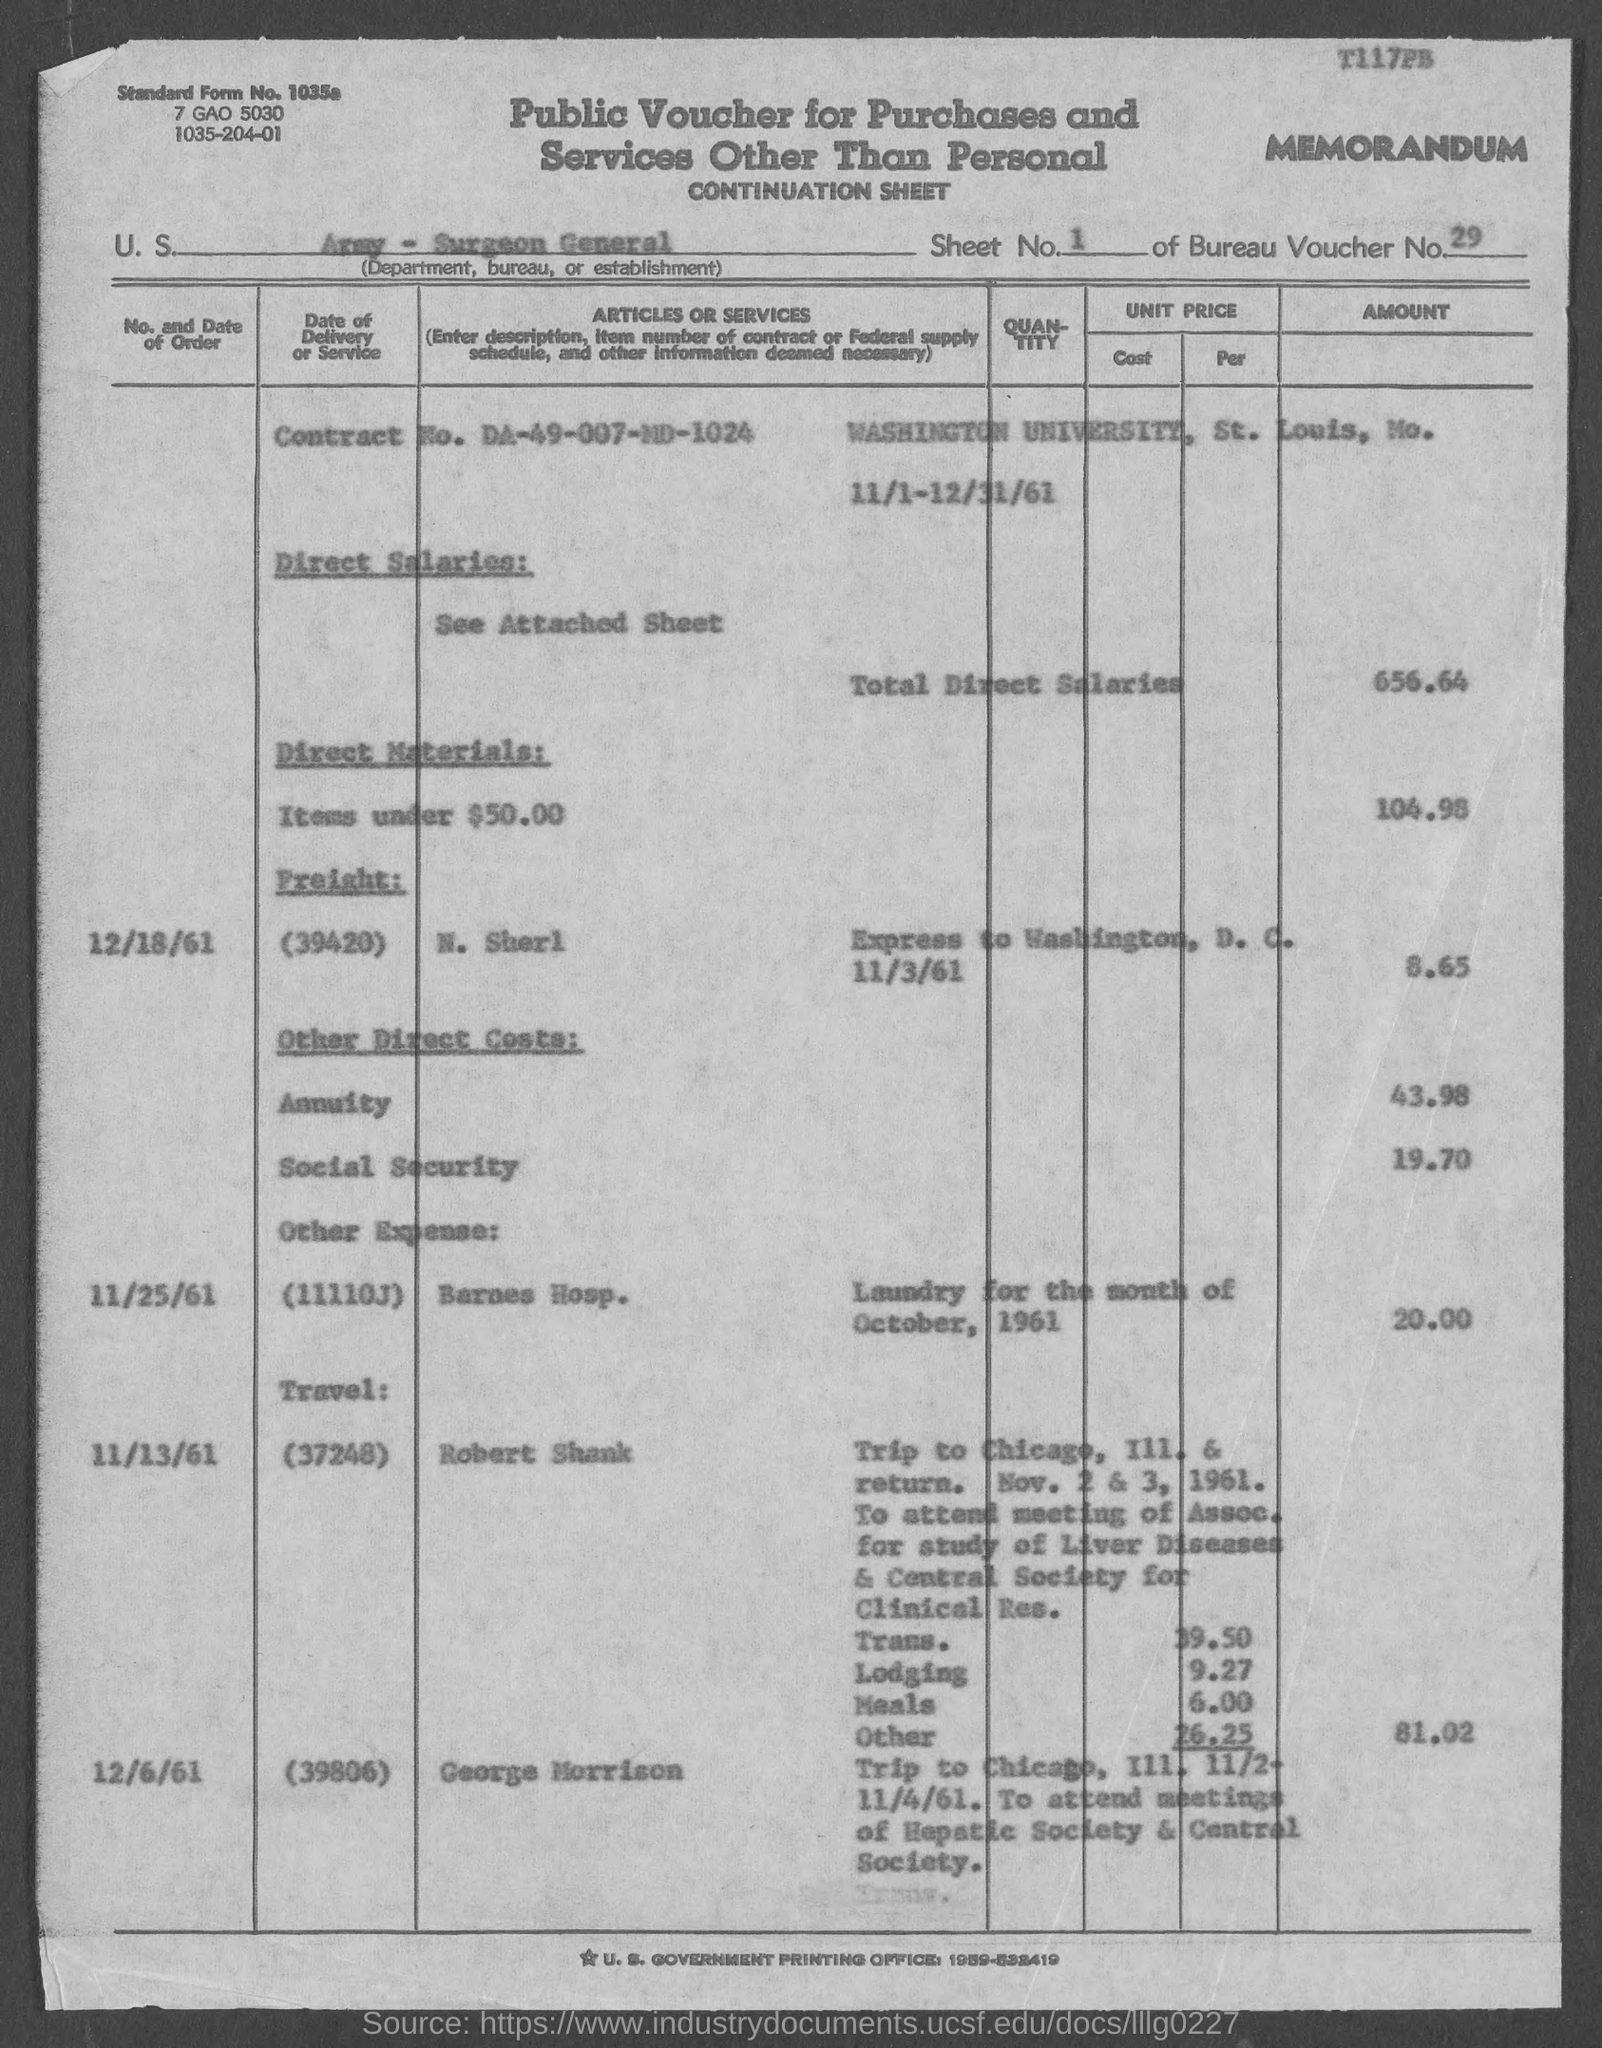Point out several critical features in this image. The total direct salaries amount is $656.64. What is the sheet number?" is a question asking for information. The contract number is DA-49-007-MD-1024. Washington University, located in St. Louis County, is a renowned institution of higher learning. The standard form number is 1035a... 